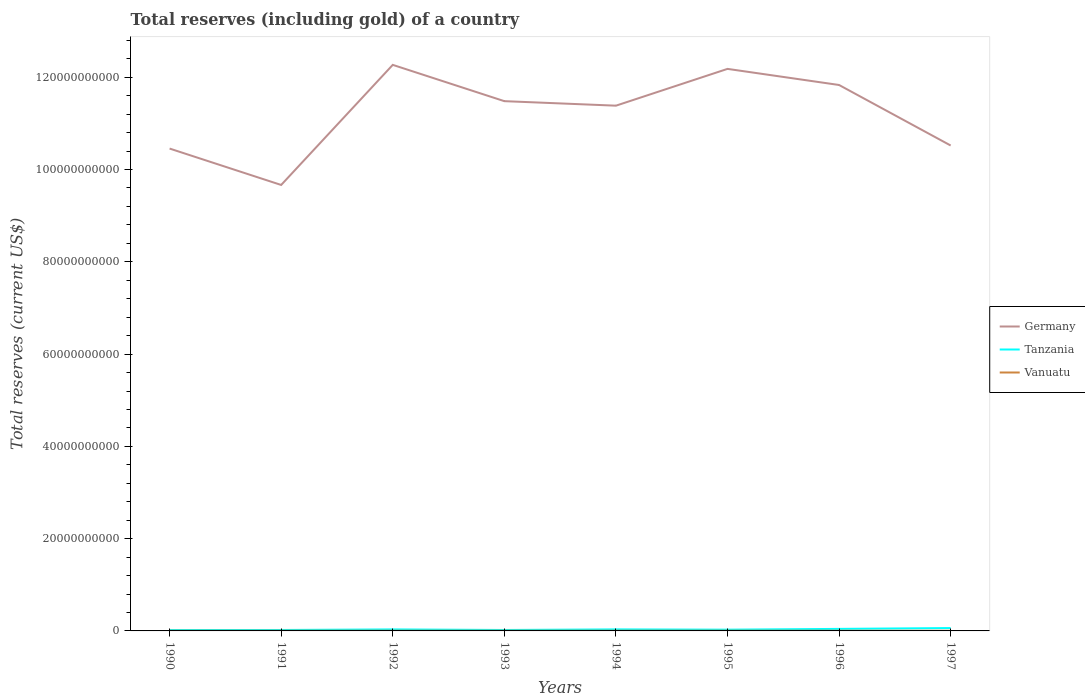How many different coloured lines are there?
Your answer should be very brief. 3. Is the number of lines equal to the number of legend labels?
Your answer should be very brief. Yes. Across all years, what is the maximum total reserves (including gold) in Vanuatu?
Make the answer very short. 3.73e+07. In which year was the total reserves (including gold) in Germany maximum?
Provide a short and direct response. 1991. What is the total total reserves (including gold) in Vanuatu in the graph?
Provide a succinct answer. 8.28e+06. What is the difference between the highest and the second highest total reserves (including gold) in Tanzania?
Your response must be concise. 4.29e+08. Is the total reserves (including gold) in Vanuatu strictly greater than the total reserves (including gold) in Germany over the years?
Your response must be concise. Yes. How many lines are there?
Your answer should be very brief. 3. Does the graph contain grids?
Your response must be concise. No. How many legend labels are there?
Provide a succinct answer. 3. What is the title of the graph?
Provide a succinct answer. Total reserves (including gold) of a country. What is the label or title of the X-axis?
Provide a succinct answer. Years. What is the label or title of the Y-axis?
Provide a succinct answer. Total reserves (current US$). What is the Total reserves (current US$) in Germany in 1990?
Make the answer very short. 1.05e+11. What is the Total reserves (current US$) in Tanzania in 1990?
Your response must be concise. 1.93e+08. What is the Total reserves (current US$) of Vanuatu in 1990?
Offer a terse response. 3.77e+07. What is the Total reserves (current US$) of Germany in 1991?
Keep it short and to the point. 9.67e+1. What is the Total reserves (current US$) in Tanzania in 1991?
Your answer should be very brief. 2.04e+08. What is the Total reserves (current US$) in Vanuatu in 1991?
Give a very brief answer. 3.98e+07. What is the Total reserves (current US$) in Germany in 1992?
Offer a terse response. 1.23e+11. What is the Total reserves (current US$) of Tanzania in 1992?
Ensure brevity in your answer.  3.27e+08. What is the Total reserves (current US$) in Vanuatu in 1992?
Make the answer very short. 4.25e+07. What is the Total reserves (current US$) in Germany in 1993?
Offer a terse response. 1.15e+11. What is the Total reserves (current US$) of Tanzania in 1993?
Offer a terse response. 2.03e+08. What is the Total reserves (current US$) of Vanuatu in 1993?
Offer a terse response. 4.56e+07. What is the Total reserves (current US$) in Germany in 1994?
Provide a short and direct response. 1.14e+11. What is the Total reserves (current US$) of Tanzania in 1994?
Give a very brief answer. 3.32e+08. What is the Total reserves (current US$) of Vanuatu in 1994?
Offer a terse response. 4.36e+07. What is the Total reserves (current US$) of Germany in 1995?
Provide a short and direct response. 1.22e+11. What is the Total reserves (current US$) of Tanzania in 1995?
Make the answer very short. 2.70e+08. What is the Total reserves (current US$) of Vanuatu in 1995?
Your answer should be very brief. 4.83e+07. What is the Total reserves (current US$) in Germany in 1996?
Offer a terse response. 1.18e+11. What is the Total reserves (current US$) in Tanzania in 1996?
Your response must be concise. 4.40e+08. What is the Total reserves (current US$) in Vanuatu in 1996?
Keep it short and to the point. 4.39e+07. What is the Total reserves (current US$) of Germany in 1997?
Offer a very short reply. 1.05e+11. What is the Total reserves (current US$) of Tanzania in 1997?
Offer a very short reply. 6.22e+08. What is the Total reserves (current US$) of Vanuatu in 1997?
Provide a short and direct response. 3.73e+07. Across all years, what is the maximum Total reserves (current US$) of Germany?
Make the answer very short. 1.23e+11. Across all years, what is the maximum Total reserves (current US$) of Tanzania?
Give a very brief answer. 6.22e+08. Across all years, what is the maximum Total reserves (current US$) of Vanuatu?
Make the answer very short. 4.83e+07. Across all years, what is the minimum Total reserves (current US$) of Germany?
Provide a succinct answer. 9.67e+1. Across all years, what is the minimum Total reserves (current US$) of Tanzania?
Provide a succinct answer. 1.93e+08. Across all years, what is the minimum Total reserves (current US$) of Vanuatu?
Your answer should be compact. 3.73e+07. What is the total Total reserves (current US$) of Germany in the graph?
Ensure brevity in your answer.  8.98e+11. What is the total Total reserves (current US$) of Tanzania in the graph?
Provide a succinct answer. 2.59e+09. What is the total Total reserves (current US$) in Vanuatu in the graph?
Ensure brevity in your answer.  3.39e+08. What is the difference between the Total reserves (current US$) in Germany in 1990 and that in 1991?
Provide a short and direct response. 7.89e+09. What is the difference between the Total reserves (current US$) of Tanzania in 1990 and that in 1991?
Ensure brevity in your answer.  -1.11e+07. What is the difference between the Total reserves (current US$) of Vanuatu in 1990 and that in 1991?
Your answer should be very brief. -2.15e+06. What is the difference between the Total reserves (current US$) in Germany in 1990 and that in 1992?
Your answer should be compact. -1.81e+1. What is the difference between the Total reserves (current US$) in Tanzania in 1990 and that in 1992?
Offer a terse response. -1.35e+08. What is the difference between the Total reserves (current US$) in Vanuatu in 1990 and that in 1992?
Offer a very short reply. -4.77e+06. What is the difference between the Total reserves (current US$) of Germany in 1990 and that in 1993?
Your response must be concise. -1.03e+1. What is the difference between the Total reserves (current US$) in Tanzania in 1990 and that in 1993?
Ensure brevity in your answer.  -1.05e+07. What is the difference between the Total reserves (current US$) of Vanuatu in 1990 and that in 1993?
Your response must be concise. -7.89e+06. What is the difference between the Total reserves (current US$) in Germany in 1990 and that in 1994?
Your response must be concise. -9.29e+09. What is the difference between the Total reserves (current US$) in Tanzania in 1990 and that in 1994?
Your response must be concise. -1.39e+08. What is the difference between the Total reserves (current US$) of Vanuatu in 1990 and that in 1994?
Provide a succinct answer. -5.88e+06. What is the difference between the Total reserves (current US$) of Germany in 1990 and that in 1995?
Offer a very short reply. -1.73e+1. What is the difference between the Total reserves (current US$) of Tanzania in 1990 and that in 1995?
Your response must be concise. -7.74e+07. What is the difference between the Total reserves (current US$) in Vanuatu in 1990 and that in 1995?
Provide a short and direct response. -1.06e+07. What is the difference between the Total reserves (current US$) of Germany in 1990 and that in 1996?
Offer a very short reply. -1.38e+1. What is the difference between the Total reserves (current US$) of Tanzania in 1990 and that in 1996?
Make the answer very short. -2.47e+08. What is the difference between the Total reserves (current US$) of Vanuatu in 1990 and that in 1996?
Your answer should be compact. -6.23e+06. What is the difference between the Total reserves (current US$) in Germany in 1990 and that in 1997?
Your response must be concise. -6.61e+08. What is the difference between the Total reserves (current US$) of Tanzania in 1990 and that in 1997?
Provide a succinct answer. -4.29e+08. What is the difference between the Total reserves (current US$) in Vanuatu in 1990 and that in 1997?
Your answer should be compact. 3.88e+05. What is the difference between the Total reserves (current US$) in Germany in 1991 and that in 1992?
Make the answer very short. -2.60e+1. What is the difference between the Total reserves (current US$) of Tanzania in 1991 and that in 1992?
Your answer should be compact. -1.23e+08. What is the difference between the Total reserves (current US$) of Vanuatu in 1991 and that in 1992?
Your response must be concise. -2.62e+06. What is the difference between the Total reserves (current US$) of Germany in 1991 and that in 1993?
Offer a terse response. -1.82e+1. What is the difference between the Total reserves (current US$) in Tanzania in 1991 and that in 1993?
Your answer should be very brief. 5.63e+05. What is the difference between the Total reserves (current US$) of Vanuatu in 1991 and that in 1993?
Provide a succinct answer. -5.75e+06. What is the difference between the Total reserves (current US$) in Germany in 1991 and that in 1994?
Provide a succinct answer. -1.72e+1. What is the difference between the Total reserves (current US$) of Tanzania in 1991 and that in 1994?
Your answer should be compact. -1.28e+08. What is the difference between the Total reserves (current US$) in Vanuatu in 1991 and that in 1994?
Offer a very short reply. -3.74e+06. What is the difference between the Total reserves (current US$) in Germany in 1991 and that in 1995?
Offer a very short reply. -2.52e+1. What is the difference between the Total reserves (current US$) in Tanzania in 1991 and that in 1995?
Your answer should be very brief. -6.63e+07. What is the difference between the Total reserves (current US$) of Vanuatu in 1991 and that in 1995?
Provide a succinct answer. -8.45e+06. What is the difference between the Total reserves (current US$) in Germany in 1991 and that in 1996?
Offer a terse response. -2.17e+1. What is the difference between the Total reserves (current US$) in Tanzania in 1991 and that in 1996?
Provide a succinct answer. -2.36e+08. What is the difference between the Total reserves (current US$) of Vanuatu in 1991 and that in 1996?
Offer a terse response. -4.09e+06. What is the difference between the Total reserves (current US$) of Germany in 1991 and that in 1997?
Offer a terse response. -8.55e+09. What is the difference between the Total reserves (current US$) in Tanzania in 1991 and that in 1997?
Keep it short and to the point. -4.18e+08. What is the difference between the Total reserves (current US$) of Vanuatu in 1991 and that in 1997?
Make the answer very short. 2.53e+06. What is the difference between the Total reserves (current US$) in Germany in 1992 and that in 1993?
Keep it short and to the point. 7.86e+09. What is the difference between the Total reserves (current US$) of Tanzania in 1992 and that in 1993?
Keep it short and to the point. 1.24e+08. What is the difference between the Total reserves (current US$) in Vanuatu in 1992 and that in 1993?
Ensure brevity in your answer.  -3.13e+06. What is the difference between the Total reserves (current US$) of Germany in 1992 and that in 1994?
Ensure brevity in your answer.  8.84e+09. What is the difference between the Total reserves (current US$) of Tanzania in 1992 and that in 1994?
Provide a succinct answer. -4.73e+06. What is the difference between the Total reserves (current US$) of Vanuatu in 1992 and that in 1994?
Provide a short and direct response. -1.12e+06. What is the difference between the Total reserves (current US$) of Germany in 1992 and that in 1995?
Your response must be concise. 8.70e+08. What is the difference between the Total reserves (current US$) in Tanzania in 1992 and that in 1995?
Your answer should be very brief. 5.71e+07. What is the difference between the Total reserves (current US$) of Vanuatu in 1992 and that in 1995?
Your answer should be compact. -5.83e+06. What is the difference between the Total reserves (current US$) in Germany in 1992 and that in 1996?
Your answer should be compact. 4.36e+09. What is the difference between the Total reserves (current US$) in Tanzania in 1992 and that in 1996?
Provide a short and direct response. -1.13e+08. What is the difference between the Total reserves (current US$) in Vanuatu in 1992 and that in 1996?
Offer a terse response. -1.47e+06. What is the difference between the Total reserves (current US$) in Germany in 1992 and that in 1997?
Offer a terse response. 1.75e+1. What is the difference between the Total reserves (current US$) of Tanzania in 1992 and that in 1997?
Make the answer very short. -2.95e+08. What is the difference between the Total reserves (current US$) in Vanuatu in 1992 and that in 1997?
Your answer should be very brief. 5.15e+06. What is the difference between the Total reserves (current US$) of Germany in 1993 and that in 1994?
Your answer should be very brief. 9.81e+08. What is the difference between the Total reserves (current US$) in Tanzania in 1993 and that in 1994?
Keep it short and to the point. -1.29e+08. What is the difference between the Total reserves (current US$) of Vanuatu in 1993 and that in 1994?
Your response must be concise. 2.01e+06. What is the difference between the Total reserves (current US$) of Germany in 1993 and that in 1995?
Ensure brevity in your answer.  -6.99e+09. What is the difference between the Total reserves (current US$) of Tanzania in 1993 and that in 1995?
Your response must be concise. -6.69e+07. What is the difference between the Total reserves (current US$) of Vanuatu in 1993 and that in 1995?
Make the answer very short. -2.70e+06. What is the difference between the Total reserves (current US$) of Germany in 1993 and that in 1996?
Ensure brevity in your answer.  -3.50e+09. What is the difference between the Total reserves (current US$) of Tanzania in 1993 and that in 1996?
Your response must be concise. -2.37e+08. What is the difference between the Total reserves (current US$) in Vanuatu in 1993 and that in 1996?
Offer a very short reply. 1.66e+06. What is the difference between the Total reserves (current US$) of Germany in 1993 and that in 1997?
Keep it short and to the point. 9.61e+09. What is the difference between the Total reserves (current US$) of Tanzania in 1993 and that in 1997?
Provide a succinct answer. -4.19e+08. What is the difference between the Total reserves (current US$) of Vanuatu in 1993 and that in 1997?
Provide a short and direct response. 8.28e+06. What is the difference between the Total reserves (current US$) of Germany in 1994 and that in 1995?
Provide a short and direct response. -7.98e+09. What is the difference between the Total reserves (current US$) of Tanzania in 1994 and that in 1995?
Offer a terse response. 6.19e+07. What is the difference between the Total reserves (current US$) of Vanuatu in 1994 and that in 1995?
Your answer should be very brief. -4.71e+06. What is the difference between the Total reserves (current US$) of Germany in 1994 and that in 1996?
Give a very brief answer. -4.48e+09. What is the difference between the Total reserves (current US$) of Tanzania in 1994 and that in 1996?
Ensure brevity in your answer.  -1.08e+08. What is the difference between the Total reserves (current US$) of Vanuatu in 1994 and that in 1996?
Give a very brief answer. -3.48e+05. What is the difference between the Total reserves (current US$) in Germany in 1994 and that in 1997?
Offer a terse response. 8.63e+09. What is the difference between the Total reserves (current US$) of Tanzania in 1994 and that in 1997?
Your answer should be compact. -2.90e+08. What is the difference between the Total reserves (current US$) in Vanuatu in 1994 and that in 1997?
Keep it short and to the point. 6.27e+06. What is the difference between the Total reserves (current US$) of Germany in 1995 and that in 1996?
Make the answer very short. 3.49e+09. What is the difference between the Total reserves (current US$) in Tanzania in 1995 and that in 1996?
Offer a very short reply. -1.70e+08. What is the difference between the Total reserves (current US$) in Vanuatu in 1995 and that in 1996?
Give a very brief answer. 4.37e+06. What is the difference between the Total reserves (current US$) of Germany in 1995 and that in 1997?
Offer a terse response. 1.66e+1. What is the difference between the Total reserves (current US$) in Tanzania in 1995 and that in 1997?
Make the answer very short. -3.52e+08. What is the difference between the Total reserves (current US$) in Vanuatu in 1995 and that in 1997?
Provide a short and direct response. 1.10e+07. What is the difference between the Total reserves (current US$) of Germany in 1996 and that in 1997?
Provide a short and direct response. 1.31e+1. What is the difference between the Total reserves (current US$) in Tanzania in 1996 and that in 1997?
Keep it short and to the point. -1.82e+08. What is the difference between the Total reserves (current US$) of Vanuatu in 1996 and that in 1997?
Keep it short and to the point. 6.62e+06. What is the difference between the Total reserves (current US$) in Germany in 1990 and the Total reserves (current US$) in Tanzania in 1991?
Provide a succinct answer. 1.04e+11. What is the difference between the Total reserves (current US$) in Germany in 1990 and the Total reserves (current US$) in Vanuatu in 1991?
Your answer should be compact. 1.05e+11. What is the difference between the Total reserves (current US$) in Tanzania in 1990 and the Total reserves (current US$) in Vanuatu in 1991?
Keep it short and to the point. 1.53e+08. What is the difference between the Total reserves (current US$) in Germany in 1990 and the Total reserves (current US$) in Tanzania in 1992?
Keep it short and to the point. 1.04e+11. What is the difference between the Total reserves (current US$) in Germany in 1990 and the Total reserves (current US$) in Vanuatu in 1992?
Provide a short and direct response. 1.05e+11. What is the difference between the Total reserves (current US$) of Tanzania in 1990 and the Total reserves (current US$) of Vanuatu in 1992?
Provide a succinct answer. 1.50e+08. What is the difference between the Total reserves (current US$) in Germany in 1990 and the Total reserves (current US$) in Tanzania in 1993?
Your answer should be compact. 1.04e+11. What is the difference between the Total reserves (current US$) in Germany in 1990 and the Total reserves (current US$) in Vanuatu in 1993?
Provide a short and direct response. 1.05e+11. What is the difference between the Total reserves (current US$) of Tanzania in 1990 and the Total reserves (current US$) of Vanuatu in 1993?
Give a very brief answer. 1.47e+08. What is the difference between the Total reserves (current US$) of Germany in 1990 and the Total reserves (current US$) of Tanzania in 1994?
Offer a terse response. 1.04e+11. What is the difference between the Total reserves (current US$) in Germany in 1990 and the Total reserves (current US$) in Vanuatu in 1994?
Ensure brevity in your answer.  1.05e+11. What is the difference between the Total reserves (current US$) of Tanzania in 1990 and the Total reserves (current US$) of Vanuatu in 1994?
Provide a short and direct response. 1.49e+08. What is the difference between the Total reserves (current US$) of Germany in 1990 and the Total reserves (current US$) of Tanzania in 1995?
Offer a terse response. 1.04e+11. What is the difference between the Total reserves (current US$) in Germany in 1990 and the Total reserves (current US$) in Vanuatu in 1995?
Offer a terse response. 1.04e+11. What is the difference between the Total reserves (current US$) in Tanzania in 1990 and the Total reserves (current US$) in Vanuatu in 1995?
Keep it short and to the point. 1.45e+08. What is the difference between the Total reserves (current US$) of Germany in 1990 and the Total reserves (current US$) of Tanzania in 1996?
Offer a terse response. 1.04e+11. What is the difference between the Total reserves (current US$) in Germany in 1990 and the Total reserves (current US$) in Vanuatu in 1996?
Ensure brevity in your answer.  1.05e+11. What is the difference between the Total reserves (current US$) of Tanzania in 1990 and the Total reserves (current US$) of Vanuatu in 1996?
Make the answer very short. 1.49e+08. What is the difference between the Total reserves (current US$) in Germany in 1990 and the Total reserves (current US$) in Tanzania in 1997?
Offer a very short reply. 1.04e+11. What is the difference between the Total reserves (current US$) of Germany in 1990 and the Total reserves (current US$) of Vanuatu in 1997?
Provide a short and direct response. 1.05e+11. What is the difference between the Total reserves (current US$) of Tanzania in 1990 and the Total reserves (current US$) of Vanuatu in 1997?
Make the answer very short. 1.55e+08. What is the difference between the Total reserves (current US$) in Germany in 1991 and the Total reserves (current US$) in Tanzania in 1992?
Offer a terse response. 9.63e+1. What is the difference between the Total reserves (current US$) in Germany in 1991 and the Total reserves (current US$) in Vanuatu in 1992?
Your answer should be very brief. 9.66e+1. What is the difference between the Total reserves (current US$) of Tanzania in 1991 and the Total reserves (current US$) of Vanuatu in 1992?
Offer a terse response. 1.61e+08. What is the difference between the Total reserves (current US$) of Germany in 1991 and the Total reserves (current US$) of Tanzania in 1993?
Offer a very short reply. 9.65e+1. What is the difference between the Total reserves (current US$) of Germany in 1991 and the Total reserves (current US$) of Vanuatu in 1993?
Offer a terse response. 9.66e+1. What is the difference between the Total reserves (current US$) in Tanzania in 1991 and the Total reserves (current US$) in Vanuatu in 1993?
Keep it short and to the point. 1.58e+08. What is the difference between the Total reserves (current US$) in Germany in 1991 and the Total reserves (current US$) in Tanzania in 1994?
Provide a succinct answer. 9.63e+1. What is the difference between the Total reserves (current US$) in Germany in 1991 and the Total reserves (current US$) in Vanuatu in 1994?
Offer a very short reply. 9.66e+1. What is the difference between the Total reserves (current US$) in Tanzania in 1991 and the Total reserves (current US$) in Vanuatu in 1994?
Your response must be concise. 1.60e+08. What is the difference between the Total reserves (current US$) of Germany in 1991 and the Total reserves (current US$) of Tanzania in 1995?
Your answer should be compact. 9.64e+1. What is the difference between the Total reserves (current US$) of Germany in 1991 and the Total reserves (current US$) of Vanuatu in 1995?
Offer a very short reply. 9.66e+1. What is the difference between the Total reserves (current US$) of Tanzania in 1991 and the Total reserves (current US$) of Vanuatu in 1995?
Offer a very short reply. 1.56e+08. What is the difference between the Total reserves (current US$) in Germany in 1991 and the Total reserves (current US$) in Tanzania in 1996?
Your response must be concise. 9.62e+1. What is the difference between the Total reserves (current US$) in Germany in 1991 and the Total reserves (current US$) in Vanuatu in 1996?
Make the answer very short. 9.66e+1. What is the difference between the Total reserves (current US$) in Tanzania in 1991 and the Total reserves (current US$) in Vanuatu in 1996?
Your answer should be very brief. 1.60e+08. What is the difference between the Total reserves (current US$) of Germany in 1991 and the Total reserves (current US$) of Tanzania in 1997?
Keep it short and to the point. 9.60e+1. What is the difference between the Total reserves (current US$) of Germany in 1991 and the Total reserves (current US$) of Vanuatu in 1997?
Your answer should be compact. 9.66e+1. What is the difference between the Total reserves (current US$) in Tanzania in 1991 and the Total reserves (current US$) in Vanuatu in 1997?
Offer a very short reply. 1.67e+08. What is the difference between the Total reserves (current US$) of Germany in 1992 and the Total reserves (current US$) of Tanzania in 1993?
Your response must be concise. 1.22e+11. What is the difference between the Total reserves (current US$) in Germany in 1992 and the Total reserves (current US$) in Vanuatu in 1993?
Offer a terse response. 1.23e+11. What is the difference between the Total reserves (current US$) in Tanzania in 1992 and the Total reserves (current US$) in Vanuatu in 1993?
Provide a short and direct response. 2.82e+08. What is the difference between the Total reserves (current US$) in Germany in 1992 and the Total reserves (current US$) in Tanzania in 1994?
Ensure brevity in your answer.  1.22e+11. What is the difference between the Total reserves (current US$) in Germany in 1992 and the Total reserves (current US$) in Vanuatu in 1994?
Ensure brevity in your answer.  1.23e+11. What is the difference between the Total reserves (current US$) of Tanzania in 1992 and the Total reserves (current US$) of Vanuatu in 1994?
Offer a terse response. 2.84e+08. What is the difference between the Total reserves (current US$) in Germany in 1992 and the Total reserves (current US$) in Tanzania in 1995?
Keep it short and to the point. 1.22e+11. What is the difference between the Total reserves (current US$) of Germany in 1992 and the Total reserves (current US$) of Vanuatu in 1995?
Your answer should be compact. 1.23e+11. What is the difference between the Total reserves (current US$) in Tanzania in 1992 and the Total reserves (current US$) in Vanuatu in 1995?
Keep it short and to the point. 2.79e+08. What is the difference between the Total reserves (current US$) of Germany in 1992 and the Total reserves (current US$) of Tanzania in 1996?
Your response must be concise. 1.22e+11. What is the difference between the Total reserves (current US$) of Germany in 1992 and the Total reserves (current US$) of Vanuatu in 1996?
Provide a short and direct response. 1.23e+11. What is the difference between the Total reserves (current US$) in Tanzania in 1992 and the Total reserves (current US$) in Vanuatu in 1996?
Ensure brevity in your answer.  2.83e+08. What is the difference between the Total reserves (current US$) in Germany in 1992 and the Total reserves (current US$) in Tanzania in 1997?
Give a very brief answer. 1.22e+11. What is the difference between the Total reserves (current US$) in Germany in 1992 and the Total reserves (current US$) in Vanuatu in 1997?
Give a very brief answer. 1.23e+11. What is the difference between the Total reserves (current US$) of Tanzania in 1992 and the Total reserves (current US$) of Vanuatu in 1997?
Keep it short and to the point. 2.90e+08. What is the difference between the Total reserves (current US$) in Germany in 1993 and the Total reserves (current US$) in Tanzania in 1994?
Your response must be concise. 1.14e+11. What is the difference between the Total reserves (current US$) of Germany in 1993 and the Total reserves (current US$) of Vanuatu in 1994?
Offer a very short reply. 1.15e+11. What is the difference between the Total reserves (current US$) of Tanzania in 1993 and the Total reserves (current US$) of Vanuatu in 1994?
Your response must be concise. 1.60e+08. What is the difference between the Total reserves (current US$) of Germany in 1993 and the Total reserves (current US$) of Tanzania in 1995?
Your answer should be very brief. 1.15e+11. What is the difference between the Total reserves (current US$) of Germany in 1993 and the Total reserves (current US$) of Vanuatu in 1995?
Offer a terse response. 1.15e+11. What is the difference between the Total reserves (current US$) in Tanzania in 1993 and the Total reserves (current US$) in Vanuatu in 1995?
Offer a very short reply. 1.55e+08. What is the difference between the Total reserves (current US$) in Germany in 1993 and the Total reserves (current US$) in Tanzania in 1996?
Provide a short and direct response. 1.14e+11. What is the difference between the Total reserves (current US$) of Germany in 1993 and the Total reserves (current US$) of Vanuatu in 1996?
Your answer should be compact. 1.15e+11. What is the difference between the Total reserves (current US$) of Tanzania in 1993 and the Total reserves (current US$) of Vanuatu in 1996?
Your response must be concise. 1.59e+08. What is the difference between the Total reserves (current US$) in Germany in 1993 and the Total reserves (current US$) in Tanzania in 1997?
Your response must be concise. 1.14e+11. What is the difference between the Total reserves (current US$) in Germany in 1993 and the Total reserves (current US$) in Vanuatu in 1997?
Give a very brief answer. 1.15e+11. What is the difference between the Total reserves (current US$) in Tanzania in 1993 and the Total reserves (current US$) in Vanuatu in 1997?
Provide a succinct answer. 1.66e+08. What is the difference between the Total reserves (current US$) of Germany in 1994 and the Total reserves (current US$) of Tanzania in 1995?
Keep it short and to the point. 1.14e+11. What is the difference between the Total reserves (current US$) in Germany in 1994 and the Total reserves (current US$) in Vanuatu in 1995?
Your response must be concise. 1.14e+11. What is the difference between the Total reserves (current US$) of Tanzania in 1994 and the Total reserves (current US$) of Vanuatu in 1995?
Your answer should be compact. 2.84e+08. What is the difference between the Total reserves (current US$) of Germany in 1994 and the Total reserves (current US$) of Tanzania in 1996?
Ensure brevity in your answer.  1.13e+11. What is the difference between the Total reserves (current US$) in Germany in 1994 and the Total reserves (current US$) in Vanuatu in 1996?
Provide a succinct answer. 1.14e+11. What is the difference between the Total reserves (current US$) of Tanzania in 1994 and the Total reserves (current US$) of Vanuatu in 1996?
Make the answer very short. 2.88e+08. What is the difference between the Total reserves (current US$) of Germany in 1994 and the Total reserves (current US$) of Tanzania in 1997?
Provide a short and direct response. 1.13e+11. What is the difference between the Total reserves (current US$) in Germany in 1994 and the Total reserves (current US$) in Vanuatu in 1997?
Offer a terse response. 1.14e+11. What is the difference between the Total reserves (current US$) of Tanzania in 1994 and the Total reserves (current US$) of Vanuatu in 1997?
Provide a short and direct response. 2.95e+08. What is the difference between the Total reserves (current US$) of Germany in 1995 and the Total reserves (current US$) of Tanzania in 1996?
Give a very brief answer. 1.21e+11. What is the difference between the Total reserves (current US$) of Germany in 1995 and the Total reserves (current US$) of Vanuatu in 1996?
Offer a very short reply. 1.22e+11. What is the difference between the Total reserves (current US$) in Tanzania in 1995 and the Total reserves (current US$) in Vanuatu in 1996?
Give a very brief answer. 2.26e+08. What is the difference between the Total reserves (current US$) in Germany in 1995 and the Total reserves (current US$) in Tanzania in 1997?
Offer a terse response. 1.21e+11. What is the difference between the Total reserves (current US$) in Germany in 1995 and the Total reserves (current US$) in Vanuatu in 1997?
Provide a short and direct response. 1.22e+11. What is the difference between the Total reserves (current US$) of Tanzania in 1995 and the Total reserves (current US$) of Vanuatu in 1997?
Keep it short and to the point. 2.33e+08. What is the difference between the Total reserves (current US$) in Germany in 1996 and the Total reserves (current US$) in Tanzania in 1997?
Your answer should be very brief. 1.18e+11. What is the difference between the Total reserves (current US$) in Germany in 1996 and the Total reserves (current US$) in Vanuatu in 1997?
Ensure brevity in your answer.  1.18e+11. What is the difference between the Total reserves (current US$) of Tanzania in 1996 and the Total reserves (current US$) of Vanuatu in 1997?
Provide a succinct answer. 4.03e+08. What is the average Total reserves (current US$) in Germany per year?
Your answer should be very brief. 1.12e+11. What is the average Total reserves (current US$) in Tanzania per year?
Ensure brevity in your answer.  3.24e+08. What is the average Total reserves (current US$) of Vanuatu per year?
Offer a very short reply. 4.23e+07. In the year 1990, what is the difference between the Total reserves (current US$) of Germany and Total reserves (current US$) of Tanzania?
Your answer should be very brief. 1.04e+11. In the year 1990, what is the difference between the Total reserves (current US$) of Germany and Total reserves (current US$) of Vanuatu?
Keep it short and to the point. 1.05e+11. In the year 1990, what is the difference between the Total reserves (current US$) in Tanzania and Total reserves (current US$) in Vanuatu?
Give a very brief answer. 1.55e+08. In the year 1991, what is the difference between the Total reserves (current US$) of Germany and Total reserves (current US$) of Tanzania?
Your response must be concise. 9.65e+1. In the year 1991, what is the difference between the Total reserves (current US$) in Germany and Total reserves (current US$) in Vanuatu?
Your answer should be very brief. 9.66e+1. In the year 1991, what is the difference between the Total reserves (current US$) of Tanzania and Total reserves (current US$) of Vanuatu?
Your response must be concise. 1.64e+08. In the year 1992, what is the difference between the Total reserves (current US$) of Germany and Total reserves (current US$) of Tanzania?
Give a very brief answer. 1.22e+11. In the year 1992, what is the difference between the Total reserves (current US$) of Germany and Total reserves (current US$) of Vanuatu?
Your answer should be compact. 1.23e+11. In the year 1992, what is the difference between the Total reserves (current US$) of Tanzania and Total reserves (current US$) of Vanuatu?
Make the answer very short. 2.85e+08. In the year 1993, what is the difference between the Total reserves (current US$) of Germany and Total reserves (current US$) of Tanzania?
Provide a short and direct response. 1.15e+11. In the year 1993, what is the difference between the Total reserves (current US$) in Germany and Total reserves (current US$) in Vanuatu?
Ensure brevity in your answer.  1.15e+11. In the year 1993, what is the difference between the Total reserves (current US$) in Tanzania and Total reserves (current US$) in Vanuatu?
Provide a succinct answer. 1.58e+08. In the year 1994, what is the difference between the Total reserves (current US$) in Germany and Total reserves (current US$) in Tanzania?
Keep it short and to the point. 1.14e+11. In the year 1994, what is the difference between the Total reserves (current US$) of Germany and Total reserves (current US$) of Vanuatu?
Keep it short and to the point. 1.14e+11. In the year 1994, what is the difference between the Total reserves (current US$) of Tanzania and Total reserves (current US$) of Vanuatu?
Offer a very short reply. 2.88e+08. In the year 1995, what is the difference between the Total reserves (current US$) of Germany and Total reserves (current US$) of Tanzania?
Provide a short and direct response. 1.22e+11. In the year 1995, what is the difference between the Total reserves (current US$) of Germany and Total reserves (current US$) of Vanuatu?
Offer a terse response. 1.22e+11. In the year 1995, what is the difference between the Total reserves (current US$) of Tanzania and Total reserves (current US$) of Vanuatu?
Provide a short and direct response. 2.22e+08. In the year 1996, what is the difference between the Total reserves (current US$) in Germany and Total reserves (current US$) in Tanzania?
Give a very brief answer. 1.18e+11. In the year 1996, what is the difference between the Total reserves (current US$) of Germany and Total reserves (current US$) of Vanuatu?
Ensure brevity in your answer.  1.18e+11. In the year 1996, what is the difference between the Total reserves (current US$) of Tanzania and Total reserves (current US$) of Vanuatu?
Offer a terse response. 3.96e+08. In the year 1997, what is the difference between the Total reserves (current US$) in Germany and Total reserves (current US$) in Tanzania?
Provide a succinct answer. 1.05e+11. In the year 1997, what is the difference between the Total reserves (current US$) in Germany and Total reserves (current US$) in Vanuatu?
Provide a succinct answer. 1.05e+11. In the year 1997, what is the difference between the Total reserves (current US$) in Tanzania and Total reserves (current US$) in Vanuatu?
Keep it short and to the point. 5.85e+08. What is the ratio of the Total reserves (current US$) of Germany in 1990 to that in 1991?
Provide a succinct answer. 1.08. What is the ratio of the Total reserves (current US$) of Tanzania in 1990 to that in 1991?
Your answer should be very brief. 0.95. What is the ratio of the Total reserves (current US$) in Vanuatu in 1990 to that in 1991?
Provide a short and direct response. 0.95. What is the ratio of the Total reserves (current US$) in Germany in 1990 to that in 1992?
Your response must be concise. 0.85. What is the ratio of the Total reserves (current US$) of Tanzania in 1990 to that in 1992?
Keep it short and to the point. 0.59. What is the ratio of the Total reserves (current US$) of Vanuatu in 1990 to that in 1992?
Offer a terse response. 0.89. What is the ratio of the Total reserves (current US$) in Germany in 1990 to that in 1993?
Provide a succinct answer. 0.91. What is the ratio of the Total reserves (current US$) in Tanzania in 1990 to that in 1993?
Ensure brevity in your answer.  0.95. What is the ratio of the Total reserves (current US$) of Vanuatu in 1990 to that in 1993?
Your answer should be very brief. 0.83. What is the ratio of the Total reserves (current US$) of Germany in 1990 to that in 1994?
Ensure brevity in your answer.  0.92. What is the ratio of the Total reserves (current US$) of Tanzania in 1990 to that in 1994?
Ensure brevity in your answer.  0.58. What is the ratio of the Total reserves (current US$) of Vanuatu in 1990 to that in 1994?
Offer a very short reply. 0.86. What is the ratio of the Total reserves (current US$) of Germany in 1990 to that in 1995?
Your answer should be compact. 0.86. What is the ratio of the Total reserves (current US$) in Tanzania in 1990 to that in 1995?
Offer a terse response. 0.71. What is the ratio of the Total reserves (current US$) in Vanuatu in 1990 to that in 1995?
Give a very brief answer. 0.78. What is the ratio of the Total reserves (current US$) in Germany in 1990 to that in 1996?
Offer a terse response. 0.88. What is the ratio of the Total reserves (current US$) of Tanzania in 1990 to that in 1996?
Provide a short and direct response. 0.44. What is the ratio of the Total reserves (current US$) of Vanuatu in 1990 to that in 1996?
Offer a terse response. 0.86. What is the ratio of the Total reserves (current US$) in Germany in 1990 to that in 1997?
Provide a succinct answer. 0.99. What is the ratio of the Total reserves (current US$) of Tanzania in 1990 to that in 1997?
Your answer should be very brief. 0.31. What is the ratio of the Total reserves (current US$) in Vanuatu in 1990 to that in 1997?
Your answer should be compact. 1.01. What is the ratio of the Total reserves (current US$) in Germany in 1991 to that in 1992?
Provide a succinct answer. 0.79. What is the ratio of the Total reserves (current US$) of Tanzania in 1991 to that in 1992?
Keep it short and to the point. 0.62. What is the ratio of the Total reserves (current US$) in Vanuatu in 1991 to that in 1992?
Your answer should be compact. 0.94. What is the ratio of the Total reserves (current US$) of Germany in 1991 to that in 1993?
Make the answer very short. 0.84. What is the ratio of the Total reserves (current US$) in Vanuatu in 1991 to that in 1993?
Your answer should be very brief. 0.87. What is the ratio of the Total reserves (current US$) in Germany in 1991 to that in 1994?
Offer a very short reply. 0.85. What is the ratio of the Total reserves (current US$) of Tanzania in 1991 to that in 1994?
Your response must be concise. 0.61. What is the ratio of the Total reserves (current US$) in Vanuatu in 1991 to that in 1994?
Make the answer very short. 0.91. What is the ratio of the Total reserves (current US$) in Germany in 1991 to that in 1995?
Your response must be concise. 0.79. What is the ratio of the Total reserves (current US$) in Tanzania in 1991 to that in 1995?
Your answer should be very brief. 0.75. What is the ratio of the Total reserves (current US$) in Vanuatu in 1991 to that in 1995?
Offer a very short reply. 0.82. What is the ratio of the Total reserves (current US$) in Germany in 1991 to that in 1996?
Your answer should be very brief. 0.82. What is the ratio of the Total reserves (current US$) of Tanzania in 1991 to that in 1996?
Make the answer very short. 0.46. What is the ratio of the Total reserves (current US$) of Vanuatu in 1991 to that in 1996?
Ensure brevity in your answer.  0.91. What is the ratio of the Total reserves (current US$) in Germany in 1991 to that in 1997?
Your answer should be compact. 0.92. What is the ratio of the Total reserves (current US$) in Tanzania in 1991 to that in 1997?
Offer a terse response. 0.33. What is the ratio of the Total reserves (current US$) in Vanuatu in 1991 to that in 1997?
Offer a terse response. 1.07. What is the ratio of the Total reserves (current US$) in Germany in 1992 to that in 1993?
Make the answer very short. 1.07. What is the ratio of the Total reserves (current US$) of Tanzania in 1992 to that in 1993?
Ensure brevity in your answer.  1.61. What is the ratio of the Total reserves (current US$) of Vanuatu in 1992 to that in 1993?
Your answer should be very brief. 0.93. What is the ratio of the Total reserves (current US$) of Germany in 1992 to that in 1994?
Ensure brevity in your answer.  1.08. What is the ratio of the Total reserves (current US$) of Tanzania in 1992 to that in 1994?
Offer a terse response. 0.99. What is the ratio of the Total reserves (current US$) in Vanuatu in 1992 to that in 1994?
Offer a terse response. 0.97. What is the ratio of the Total reserves (current US$) of Germany in 1992 to that in 1995?
Provide a succinct answer. 1.01. What is the ratio of the Total reserves (current US$) of Tanzania in 1992 to that in 1995?
Offer a terse response. 1.21. What is the ratio of the Total reserves (current US$) in Vanuatu in 1992 to that in 1995?
Your answer should be very brief. 0.88. What is the ratio of the Total reserves (current US$) in Germany in 1992 to that in 1996?
Your answer should be very brief. 1.04. What is the ratio of the Total reserves (current US$) in Tanzania in 1992 to that in 1996?
Your answer should be compact. 0.74. What is the ratio of the Total reserves (current US$) of Vanuatu in 1992 to that in 1996?
Your response must be concise. 0.97. What is the ratio of the Total reserves (current US$) of Germany in 1992 to that in 1997?
Offer a terse response. 1.17. What is the ratio of the Total reserves (current US$) in Tanzania in 1992 to that in 1997?
Make the answer very short. 0.53. What is the ratio of the Total reserves (current US$) in Vanuatu in 1992 to that in 1997?
Offer a terse response. 1.14. What is the ratio of the Total reserves (current US$) of Germany in 1993 to that in 1994?
Your answer should be compact. 1.01. What is the ratio of the Total reserves (current US$) of Tanzania in 1993 to that in 1994?
Your answer should be compact. 0.61. What is the ratio of the Total reserves (current US$) in Vanuatu in 1993 to that in 1994?
Offer a terse response. 1.05. What is the ratio of the Total reserves (current US$) of Germany in 1993 to that in 1995?
Offer a very short reply. 0.94. What is the ratio of the Total reserves (current US$) in Tanzania in 1993 to that in 1995?
Make the answer very short. 0.75. What is the ratio of the Total reserves (current US$) in Vanuatu in 1993 to that in 1995?
Ensure brevity in your answer.  0.94. What is the ratio of the Total reserves (current US$) of Germany in 1993 to that in 1996?
Provide a succinct answer. 0.97. What is the ratio of the Total reserves (current US$) of Tanzania in 1993 to that in 1996?
Your answer should be very brief. 0.46. What is the ratio of the Total reserves (current US$) of Vanuatu in 1993 to that in 1996?
Provide a succinct answer. 1.04. What is the ratio of the Total reserves (current US$) of Germany in 1993 to that in 1997?
Ensure brevity in your answer.  1.09. What is the ratio of the Total reserves (current US$) of Tanzania in 1993 to that in 1997?
Ensure brevity in your answer.  0.33. What is the ratio of the Total reserves (current US$) in Vanuatu in 1993 to that in 1997?
Ensure brevity in your answer.  1.22. What is the ratio of the Total reserves (current US$) in Germany in 1994 to that in 1995?
Your answer should be very brief. 0.93. What is the ratio of the Total reserves (current US$) in Tanzania in 1994 to that in 1995?
Keep it short and to the point. 1.23. What is the ratio of the Total reserves (current US$) of Vanuatu in 1994 to that in 1995?
Your answer should be very brief. 0.9. What is the ratio of the Total reserves (current US$) in Germany in 1994 to that in 1996?
Your response must be concise. 0.96. What is the ratio of the Total reserves (current US$) in Tanzania in 1994 to that in 1996?
Give a very brief answer. 0.75. What is the ratio of the Total reserves (current US$) in Germany in 1994 to that in 1997?
Make the answer very short. 1.08. What is the ratio of the Total reserves (current US$) of Tanzania in 1994 to that in 1997?
Your answer should be compact. 0.53. What is the ratio of the Total reserves (current US$) in Vanuatu in 1994 to that in 1997?
Your answer should be very brief. 1.17. What is the ratio of the Total reserves (current US$) in Germany in 1995 to that in 1996?
Provide a succinct answer. 1.03. What is the ratio of the Total reserves (current US$) in Tanzania in 1995 to that in 1996?
Give a very brief answer. 0.61. What is the ratio of the Total reserves (current US$) of Vanuatu in 1995 to that in 1996?
Your answer should be very brief. 1.1. What is the ratio of the Total reserves (current US$) of Germany in 1995 to that in 1997?
Your response must be concise. 1.16. What is the ratio of the Total reserves (current US$) in Tanzania in 1995 to that in 1997?
Your answer should be compact. 0.43. What is the ratio of the Total reserves (current US$) in Vanuatu in 1995 to that in 1997?
Offer a terse response. 1.29. What is the ratio of the Total reserves (current US$) in Germany in 1996 to that in 1997?
Your answer should be very brief. 1.12. What is the ratio of the Total reserves (current US$) of Tanzania in 1996 to that in 1997?
Ensure brevity in your answer.  0.71. What is the ratio of the Total reserves (current US$) in Vanuatu in 1996 to that in 1997?
Offer a terse response. 1.18. What is the difference between the highest and the second highest Total reserves (current US$) in Germany?
Keep it short and to the point. 8.70e+08. What is the difference between the highest and the second highest Total reserves (current US$) of Tanzania?
Make the answer very short. 1.82e+08. What is the difference between the highest and the second highest Total reserves (current US$) in Vanuatu?
Your response must be concise. 2.70e+06. What is the difference between the highest and the lowest Total reserves (current US$) in Germany?
Keep it short and to the point. 2.60e+1. What is the difference between the highest and the lowest Total reserves (current US$) in Tanzania?
Make the answer very short. 4.29e+08. What is the difference between the highest and the lowest Total reserves (current US$) of Vanuatu?
Provide a succinct answer. 1.10e+07. 